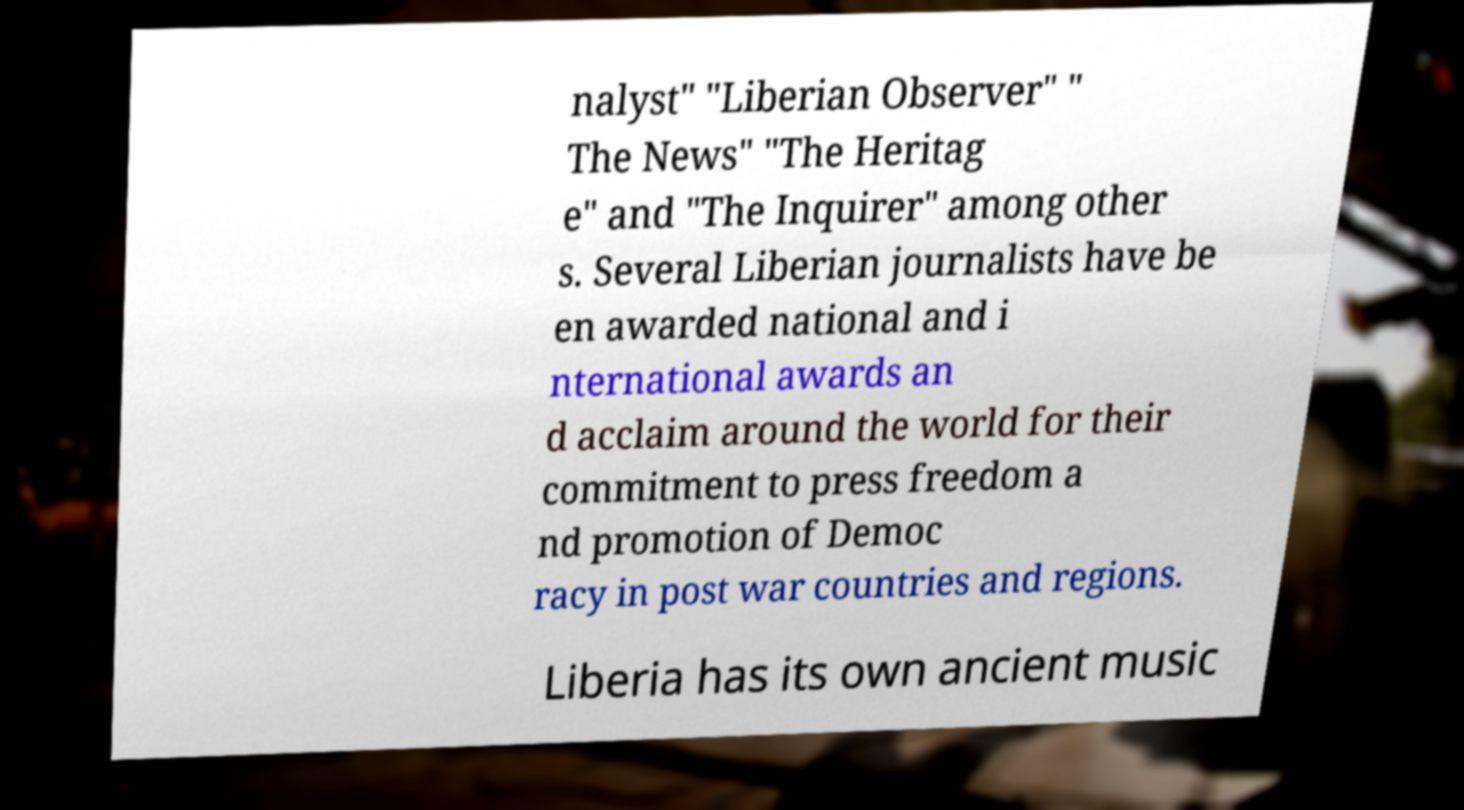For documentation purposes, I need the text within this image transcribed. Could you provide that? nalyst" "Liberian Observer" " The News" "The Heritag e" and "The Inquirer" among other s. Several Liberian journalists have be en awarded national and i nternational awards an d acclaim around the world for their commitment to press freedom a nd promotion of Democ racy in post war countries and regions. Liberia has its own ancient music 